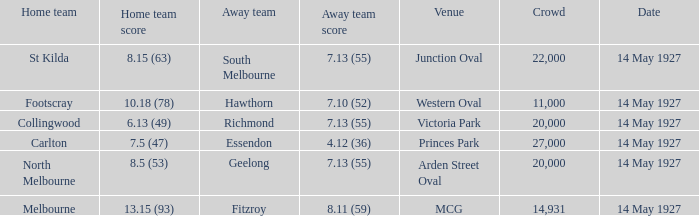Which team, playing away from home, scored 4.12 (36)? Essendon. 